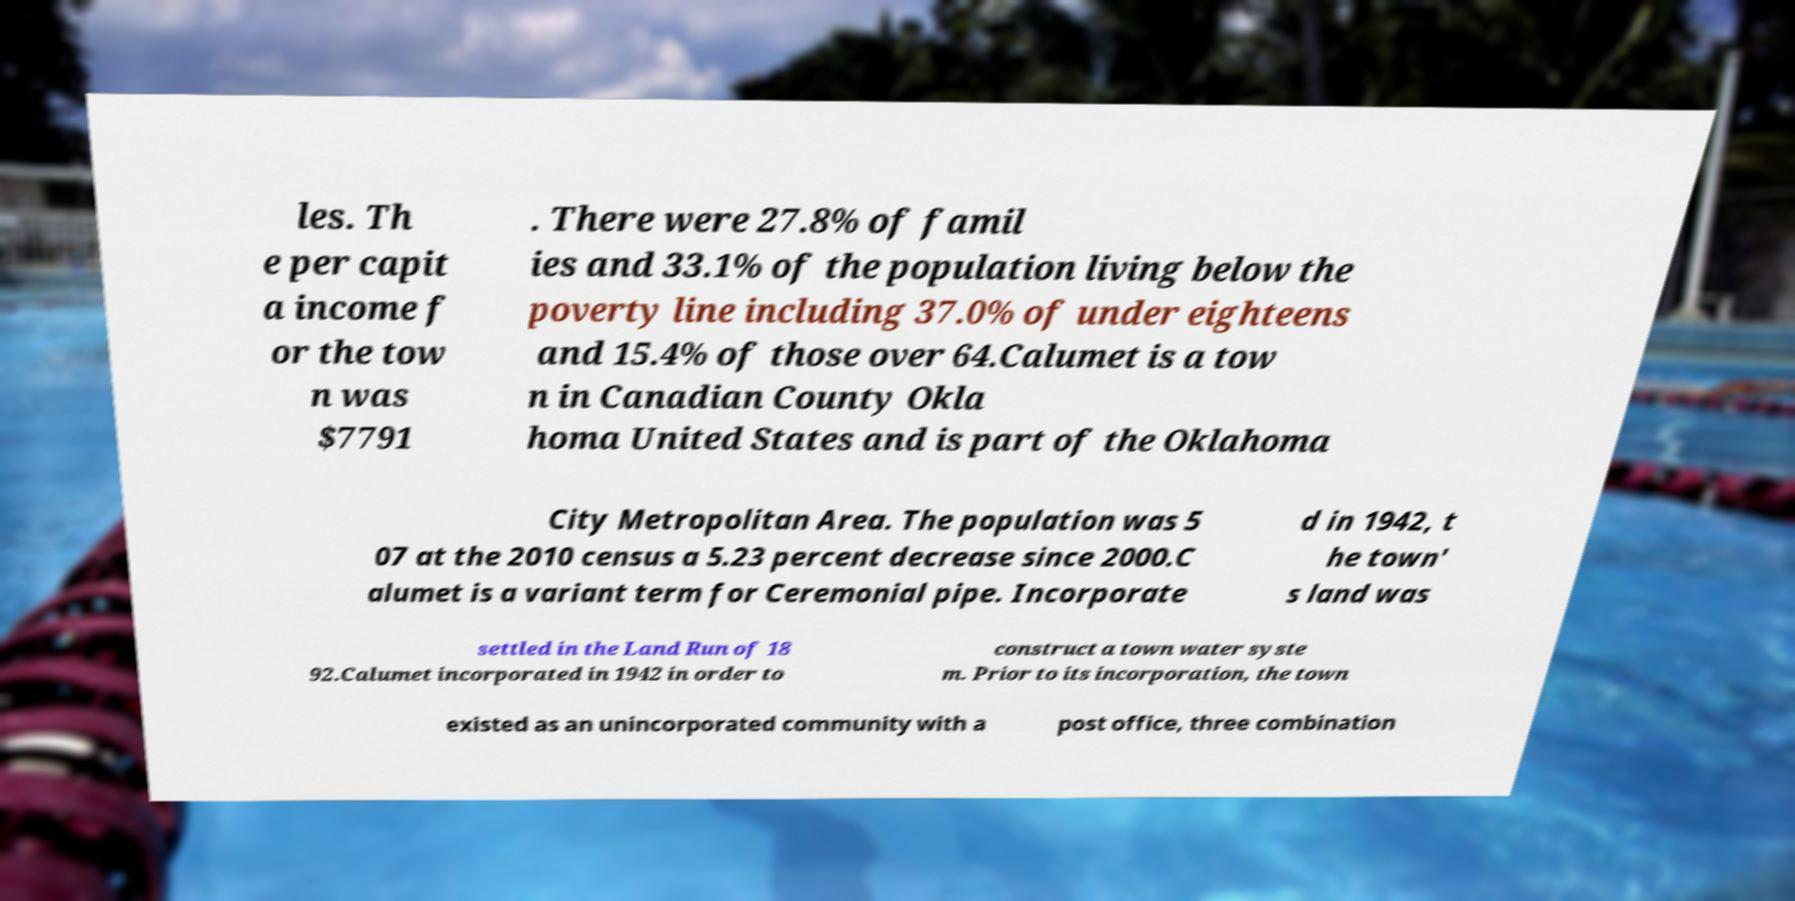Can you accurately transcribe the text from the provided image for me? les. Th e per capit a income f or the tow n was $7791 . There were 27.8% of famil ies and 33.1% of the population living below the poverty line including 37.0% of under eighteens and 15.4% of those over 64.Calumet is a tow n in Canadian County Okla homa United States and is part of the Oklahoma City Metropolitan Area. The population was 5 07 at the 2010 census a 5.23 percent decrease since 2000.C alumet is a variant term for Ceremonial pipe. Incorporate d in 1942, t he town' s land was settled in the Land Run of 18 92.Calumet incorporated in 1942 in order to construct a town water syste m. Prior to its incorporation, the town existed as an unincorporated community with a post office, three combination 